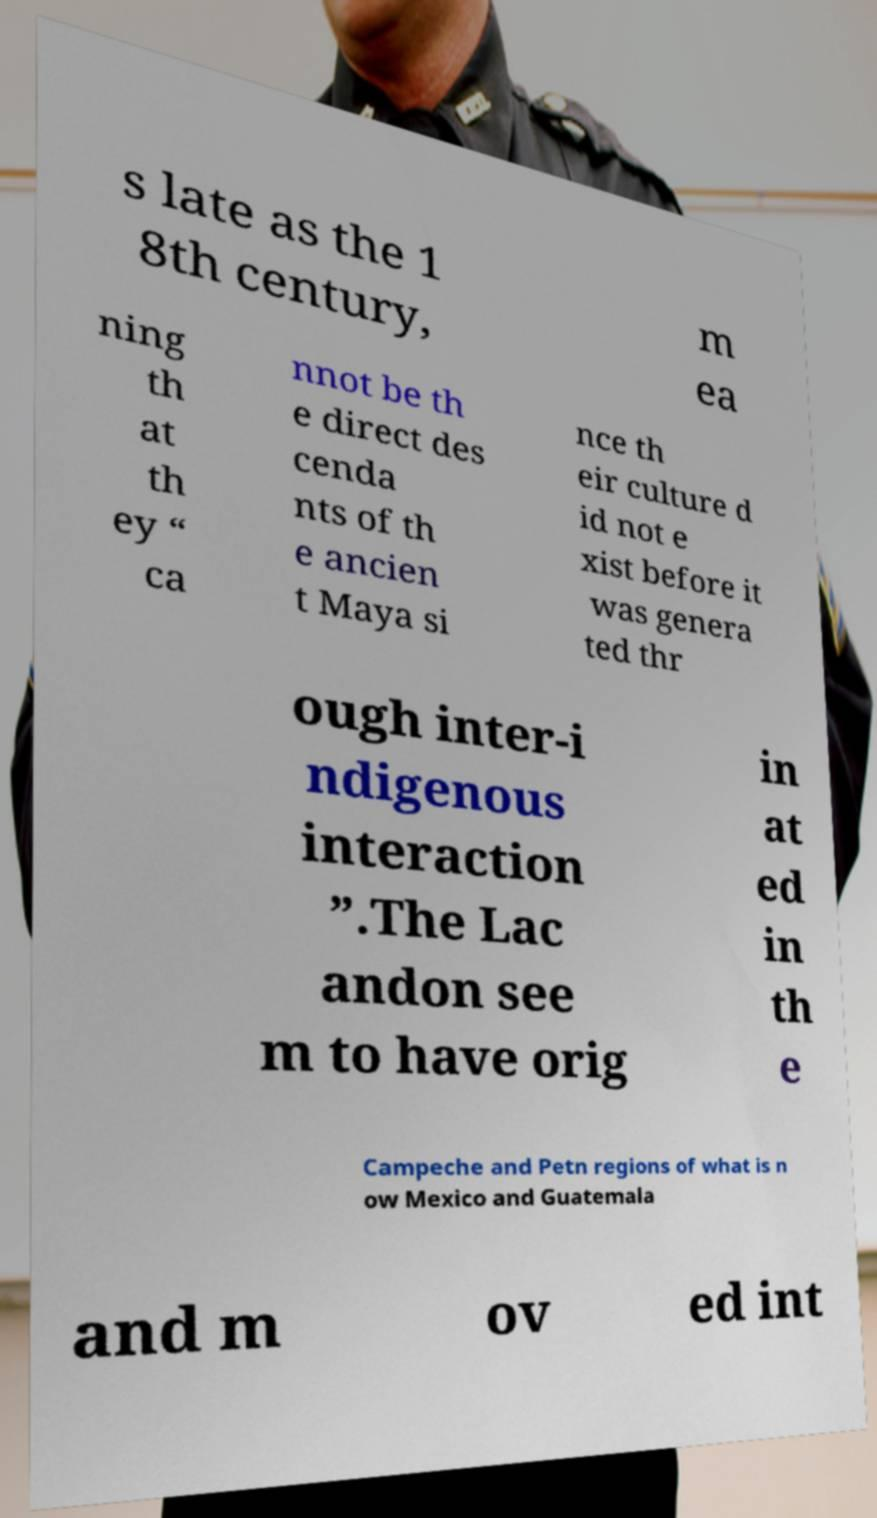Could you extract and type out the text from this image? s late as the 1 8th century, m ea ning th at th ey “ ca nnot be th e direct des cenda nts of th e ancien t Maya si nce th eir culture d id not e xist before it was genera ted thr ough inter-i ndigenous interaction ”.The Lac andon see m to have orig in at ed in th e Campeche and Petn regions of what is n ow Mexico and Guatemala and m ov ed int 